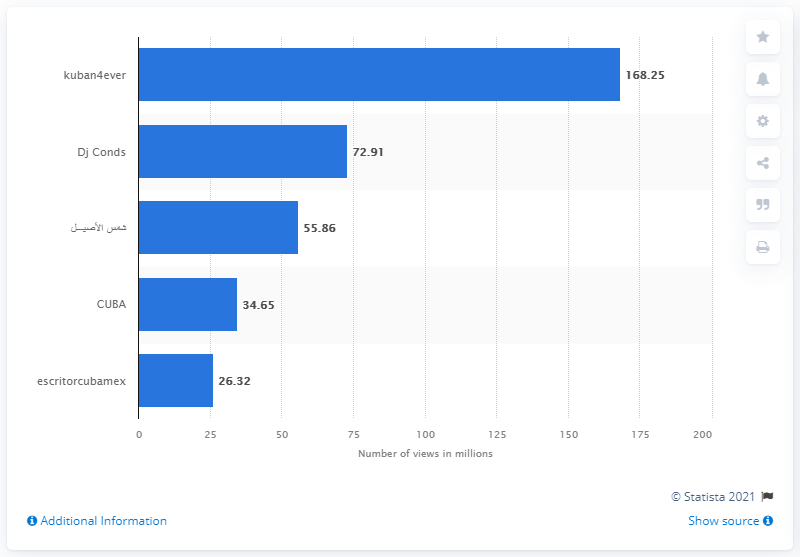Identify some key points in this picture. As of March 2021, the most viewed YouTube channel in Cuba was "kuban4ever. 